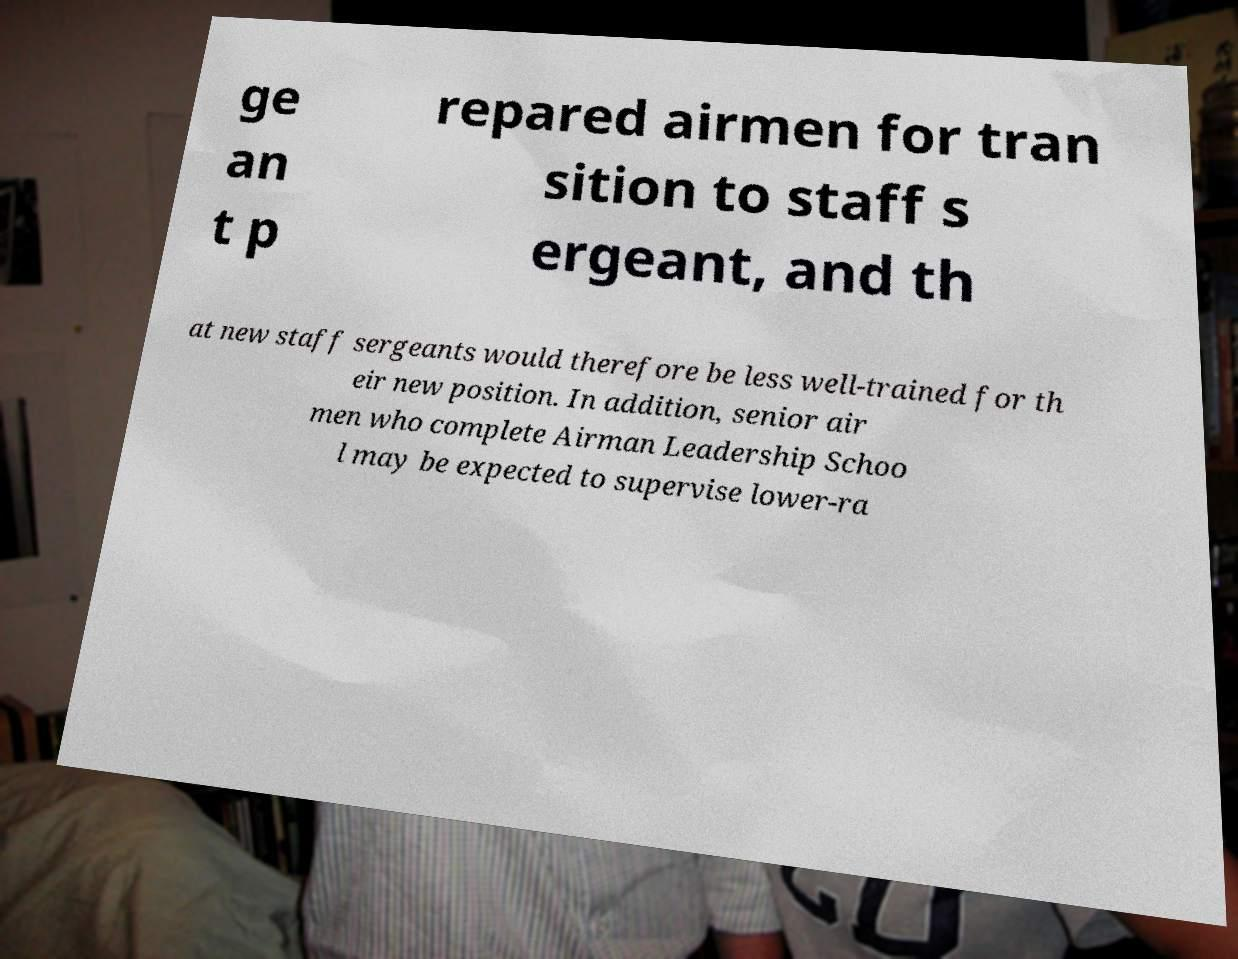Can you accurately transcribe the text from the provided image for me? ge an t p repared airmen for tran sition to staff s ergeant, and th at new staff sergeants would therefore be less well-trained for th eir new position. In addition, senior air men who complete Airman Leadership Schoo l may be expected to supervise lower-ra 